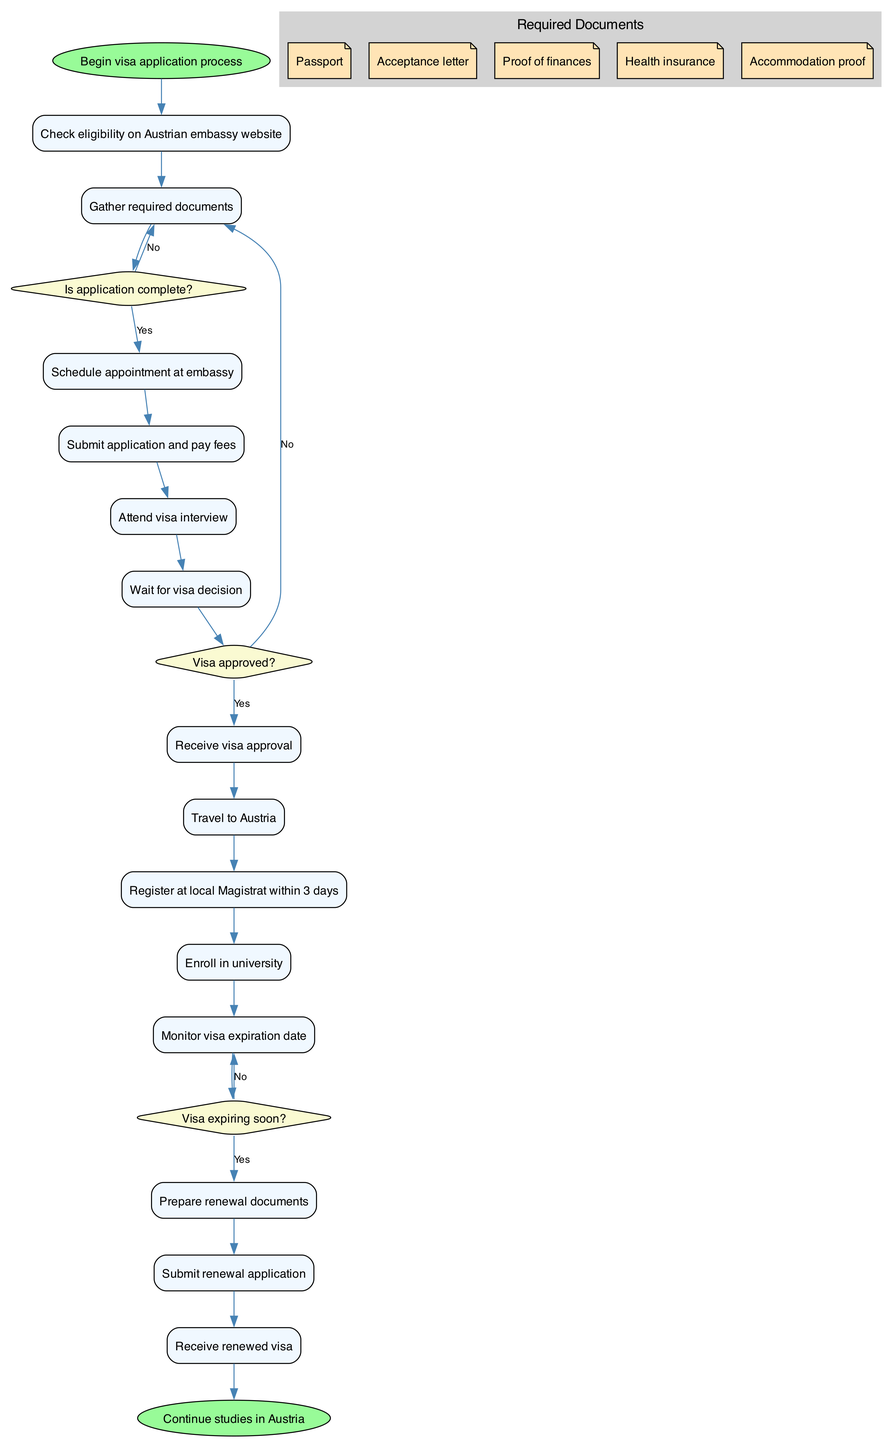What is the first activity in applying for a student visa? The first activity in the diagram, starting from the 'start' node, is "Check eligibility on Austrian embassy website."
Answer: Check eligibility on Austrian embassy website How many decisions are present in the diagram? By counting the nodes categorized as decisions (shaped as diamonds), we find there are three decisions: "Is application complete?", "Visa approved?", and "Visa expiring soon?".
Answer: 3 What is required before submitting the visa application? The document required is the "Acceptance letter," which is included in the cluster labeled 'Required Documents.' Before submitting, one must gather essential documents, including the acceptance letter.
Answer: Acceptance letter What happens if the visa application is incomplete? If the application is incomplete, the flow directs back to "Gather required documents" based on the arrow stemming from the decision "Is application complete?" that leads to this activity when answered 'No.'
Answer: Gather required documents What is the final step after receiving the renewed visa? The last activity in the flow is the 'end' node, which states "Continue studies in Austria," occurring after "Receive renewed visa."
Answer: Continue studies in Austria What is an activity that occurs after visa approval? After receiving visa approval, the next activity according to the flow is "Travel to Austria." Approval leads directly to travel plans.
Answer: Travel to Austria What document is necessary to prove financial means? The required document here is "Proof of finances," which is explicitly mentioned among the necessary paperwork listed in the 'Required Documents' section.
Answer: Proof of finances If a visa is expiring soon, what is the first step according to the diagram? Upon checking the decision "Visa expiring soon?", if answered 'Yes,' the flow leads to "Prepare renewal documents" immediately after monitoring the expiration date.
Answer: Prepare renewal documents What is the shape of the nodes representing activities? The nodes representing activities are shown as rectangles with rounded corners, indicating their nature as activities in this flow.
Answer: Rectangle 